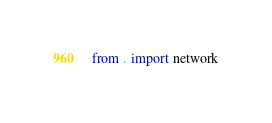Convert code to text. <code><loc_0><loc_0><loc_500><loc_500><_Python_>from . import network</code> 